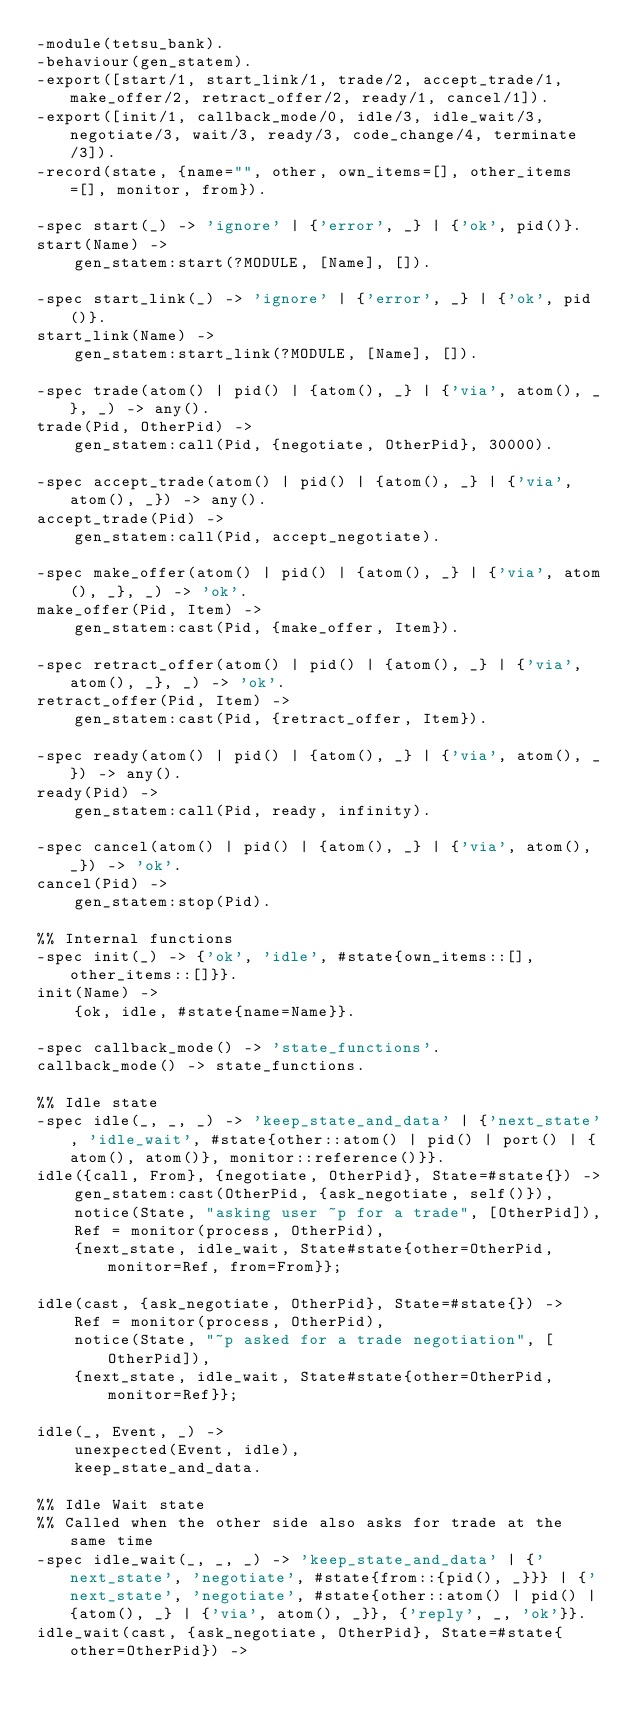<code> <loc_0><loc_0><loc_500><loc_500><_Erlang_>-module(tetsu_bank).
-behaviour(gen_statem).
-export([start/1, start_link/1, trade/2, accept_trade/1, make_offer/2, retract_offer/2, ready/1, cancel/1]).
-export([init/1, callback_mode/0, idle/3, idle_wait/3, negotiate/3, wait/3, ready/3, code_change/4, terminate/3]).
-record(state, {name="", other, own_items=[], other_items=[], monitor, from}).

-spec start(_) -> 'ignore' | {'error', _} | {'ok', pid()}.
start(Name) ->
    gen_statem:start(?MODULE, [Name], []).

-spec start_link(_) -> 'ignore' | {'error', _} | {'ok', pid()}.
start_link(Name) ->
    gen_statem:start_link(?MODULE, [Name], []).

-spec trade(atom() | pid() | {atom(), _} | {'via', atom(), _}, _) -> any().
trade(Pid, OtherPid) ->
    gen_statem:call(Pid, {negotiate, OtherPid}, 30000).

-spec accept_trade(atom() | pid() | {atom(), _} | {'via', atom(), _}) -> any().
accept_trade(Pid) ->
    gen_statem:call(Pid, accept_negotiate).

-spec make_offer(atom() | pid() | {atom(), _} | {'via', atom(), _}, _) -> 'ok'.
make_offer(Pid, Item) ->
    gen_statem:cast(Pid, {make_offer, Item}).

-spec retract_offer(atom() | pid() | {atom(), _} | {'via', atom(), _}, _) -> 'ok'.
retract_offer(Pid, Item) ->
    gen_statem:cast(Pid, {retract_offer, Item}).

-spec ready(atom() | pid() | {atom(), _} | {'via', atom(), _}) -> any().
ready(Pid) ->
    gen_statem:call(Pid, ready, infinity).

-spec cancel(atom() | pid() | {atom(), _} | {'via', atom(), _}) -> 'ok'.
cancel(Pid) ->
    gen_statem:stop(Pid).

%% Internal functions
-spec init(_) -> {'ok', 'idle', #state{own_items::[], other_items::[]}}.
init(Name) ->
    {ok, idle, #state{name=Name}}.

-spec callback_mode() -> 'state_functions'.
callback_mode() -> state_functions.

%% Idle state
-spec idle(_, _, _) -> 'keep_state_and_data' | {'next_state', 'idle_wait', #state{other::atom() | pid() | port() | {atom(), atom()}, monitor::reference()}}.
idle({call, From}, {negotiate, OtherPid}, State=#state{}) ->
    gen_statem:cast(OtherPid, {ask_negotiate, self()}),
    notice(State, "asking user ~p for a trade", [OtherPid]),
    Ref = monitor(process, OtherPid),
    {next_state, idle_wait, State#state{other=OtherPid, monitor=Ref, from=From}};

idle(cast, {ask_negotiate, OtherPid}, State=#state{}) ->
    Ref = monitor(process, OtherPid),
    notice(State, "~p asked for a trade negotiation", [OtherPid]),
    {next_state, idle_wait, State#state{other=OtherPid, monitor=Ref}};

idle(_, Event, _) ->
    unexpected(Event, idle),
    keep_state_and_data.

%% Idle Wait state
%% Called when the other side also asks for trade at the same time
-spec idle_wait(_, _, _) -> 'keep_state_and_data' | {'next_state', 'negotiate', #state{from::{pid(), _}}} | {'next_state', 'negotiate', #state{other::atom() | pid() | {atom(), _} | {'via', atom(), _}}, {'reply', _, 'ok'}}.
idle_wait(cast, {ask_negotiate, OtherPid}, State=#state{other=OtherPid}) -></code> 